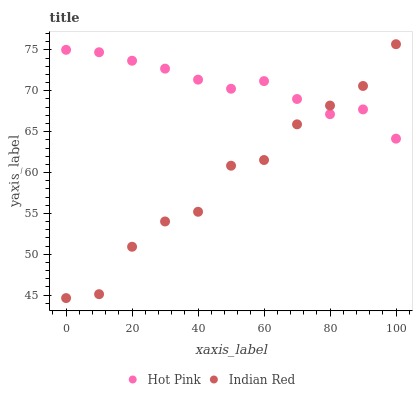Does Indian Red have the minimum area under the curve?
Answer yes or no. Yes. Does Hot Pink have the maximum area under the curve?
Answer yes or no. Yes. Does Indian Red have the maximum area under the curve?
Answer yes or no. No. Is Hot Pink the smoothest?
Answer yes or no. Yes. Is Indian Red the roughest?
Answer yes or no. Yes. Is Indian Red the smoothest?
Answer yes or no. No. Does Indian Red have the lowest value?
Answer yes or no. Yes. Does Indian Red have the highest value?
Answer yes or no. Yes. Does Hot Pink intersect Indian Red?
Answer yes or no. Yes. Is Hot Pink less than Indian Red?
Answer yes or no. No. Is Hot Pink greater than Indian Red?
Answer yes or no. No. 